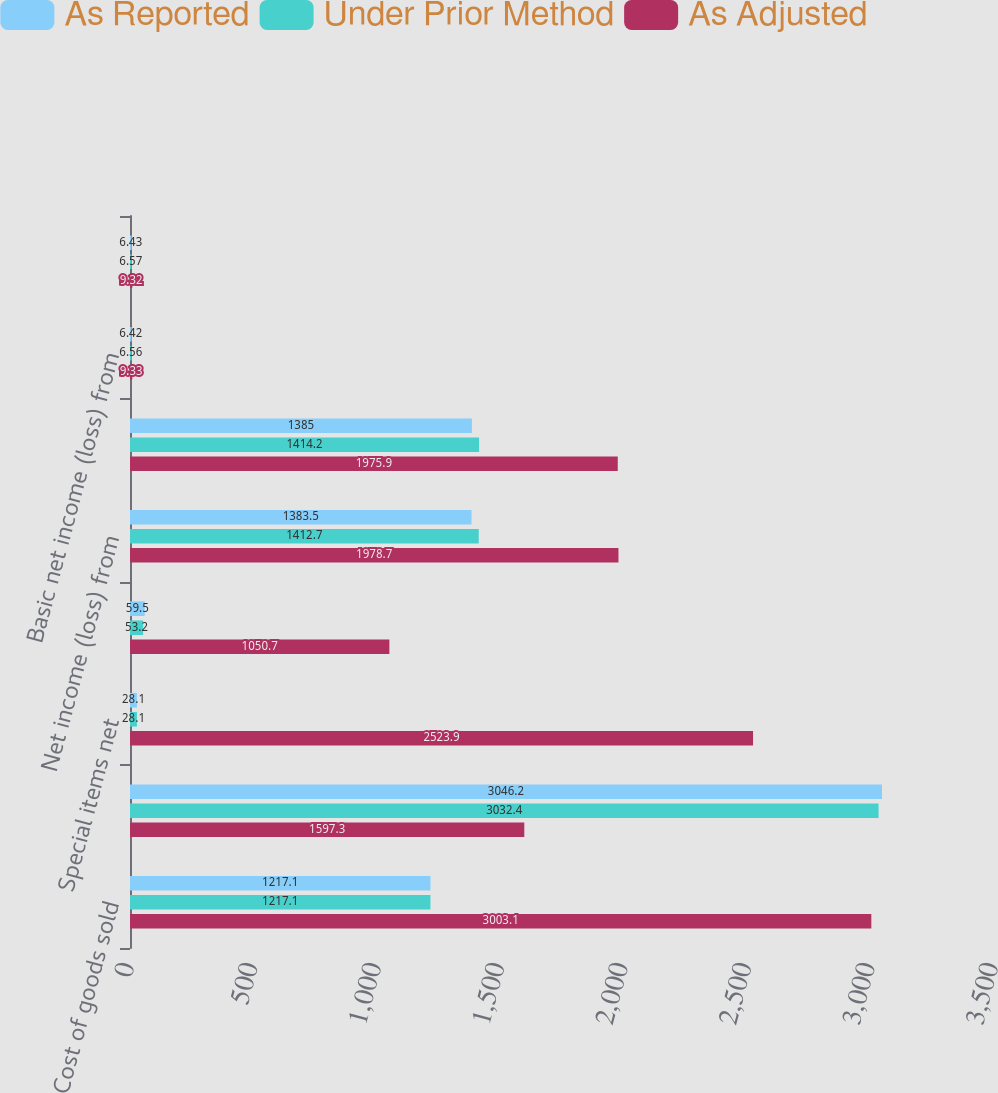Convert chart. <chart><loc_0><loc_0><loc_500><loc_500><stacked_bar_chart><ecel><fcel>Cost of goods sold<fcel>Marketing general and<fcel>Special items net<fcel>Income tax benefit (expense)<fcel>Net income (loss) from<fcel>Net income (loss) attributable<fcel>Basic net income (loss) from<fcel>Basic net income (loss)<nl><fcel>As Reported<fcel>1217.1<fcel>3046.2<fcel>28.1<fcel>59.5<fcel>1383.5<fcel>1385<fcel>6.42<fcel>6.43<nl><fcel>Under Prior Method<fcel>1217.1<fcel>3032.4<fcel>28.1<fcel>53.2<fcel>1412.7<fcel>1414.2<fcel>6.56<fcel>6.57<nl><fcel>As Adjusted<fcel>3003.1<fcel>1597.3<fcel>2523.9<fcel>1050.7<fcel>1978.7<fcel>1975.9<fcel>9.33<fcel>9.32<nl></chart> 